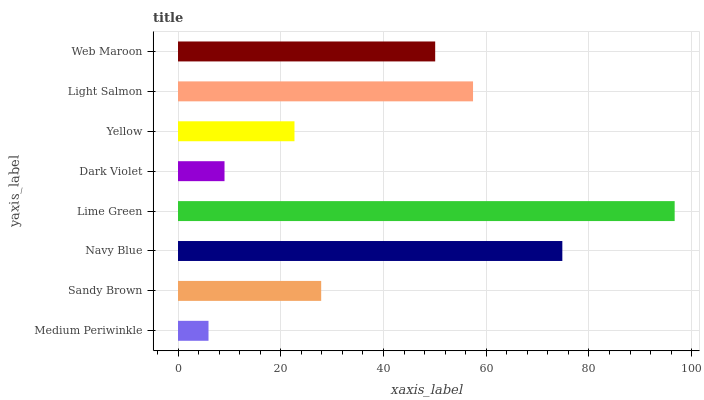Is Medium Periwinkle the minimum?
Answer yes or no. Yes. Is Lime Green the maximum?
Answer yes or no. Yes. Is Sandy Brown the minimum?
Answer yes or no. No. Is Sandy Brown the maximum?
Answer yes or no. No. Is Sandy Brown greater than Medium Periwinkle?
Answer yes or no. Yes. Is Medium Periwinkle less than Sandy Brown?
Answer yes or no. Yes. Is Medium Periwinkle greater than Sandy Brown?
Answer yes or no. No. Is Sandy Brown less than Medium Periwinkle?
Answer yes or no. No. Is Web Maroon the high median?
Answer yes or no. Yes. Is Sandy Brown the low median?
Answer yes or no. Yes. Is Medium Periwinkle the high median?
Answer yes or no. No. Is Lime Green the low median?
Answer yes or no. No. 